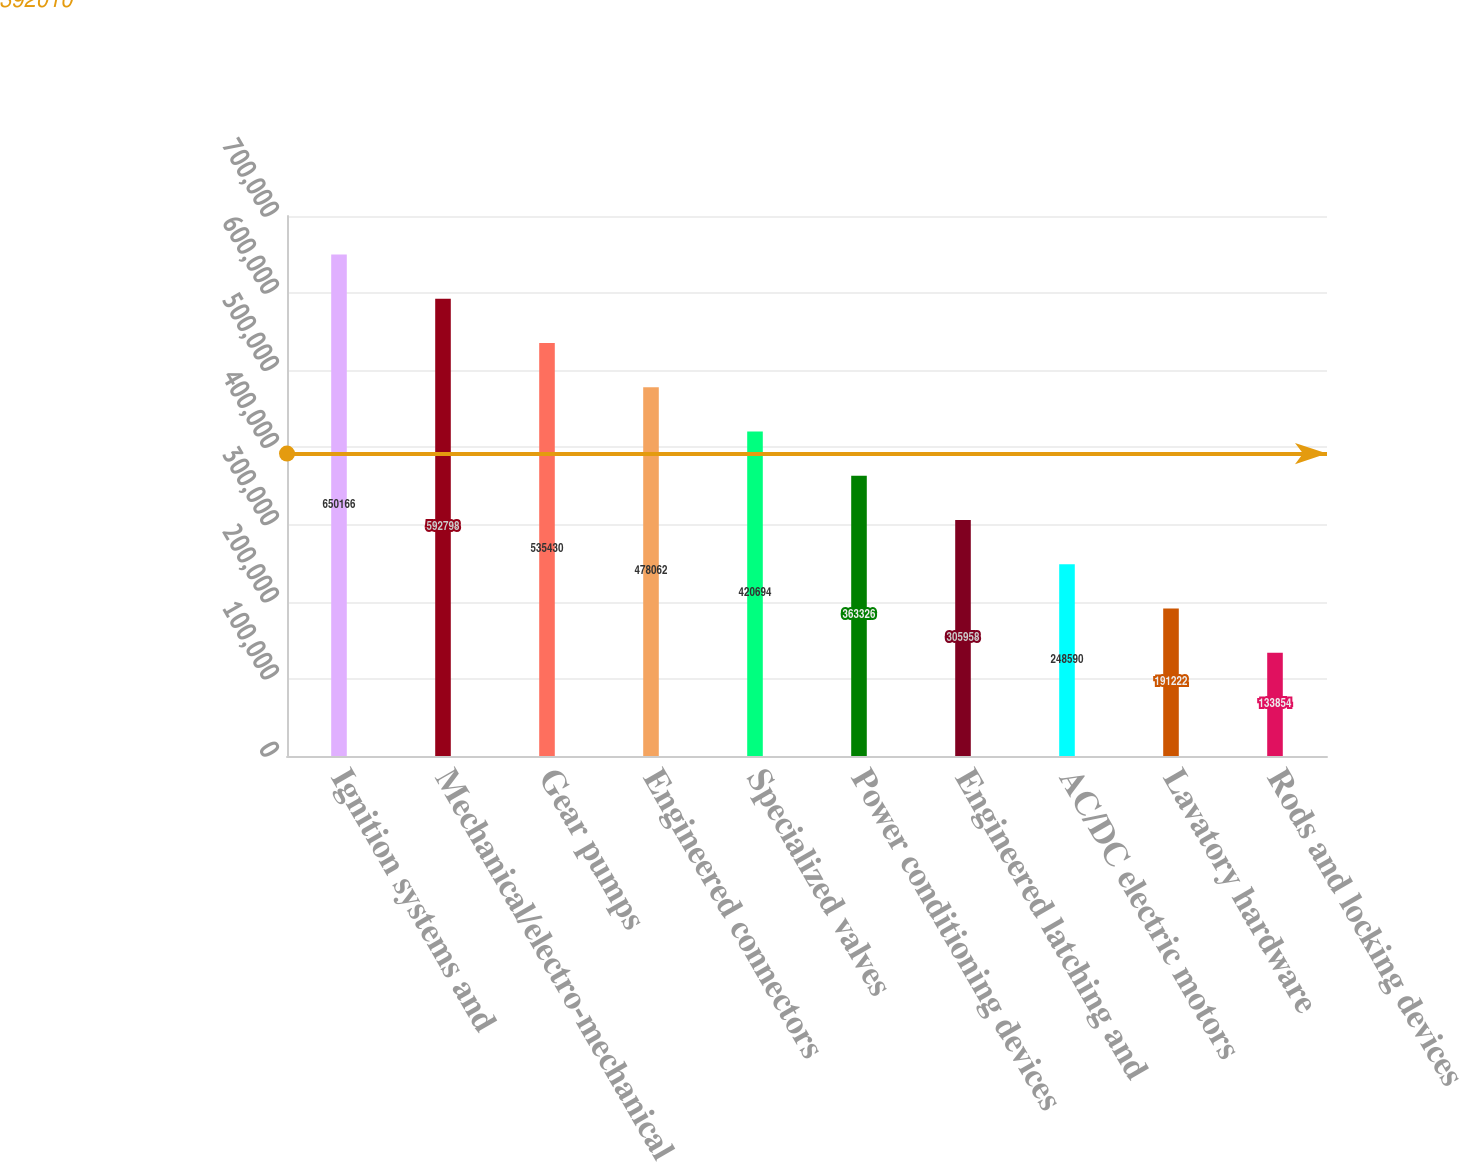<chart> <loc_0><loc_0><loc_500><loc_500><bar_chart><fcel>Ignition systems and<fcel>Mechanical/electro-mechanical<fcel>Gear pumps<fcel>Engineered connectors<fcel>Specialized valves<fcel>Power conditioning devices<fcel>Engineered latching and<fcel>AC/DC electric motors<fcel>Lavatory hardware<fcel>Rods and locking devices<nl><fcel>650166<fcel>592798<fcel>535430<fcel>478062<fcel>420694<fcel>363326<fcel>305958<fcel>248590<fcel>191222<fcel>133854<nl></chart> 